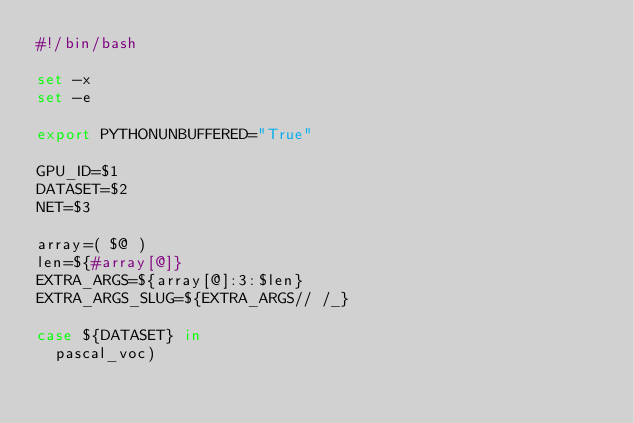Convert code to text. <code><loc_0><loc_0><loc_500><loc_500><_Bash_>#!/bin/bash

set -x
set -e

export PYTHONUNBUFFERED="True"

GPU_ID=$1
DATASET=$2
NET=$3

array=( $@ )
len=${#array[@]}
EXTRA_ARGS=${array[@]:3:$len}
EXTRA_ARGS_SLUG=${EXTRA_ARGS// /_}

case ${DATASET} in
  pascal_voc)</code> 